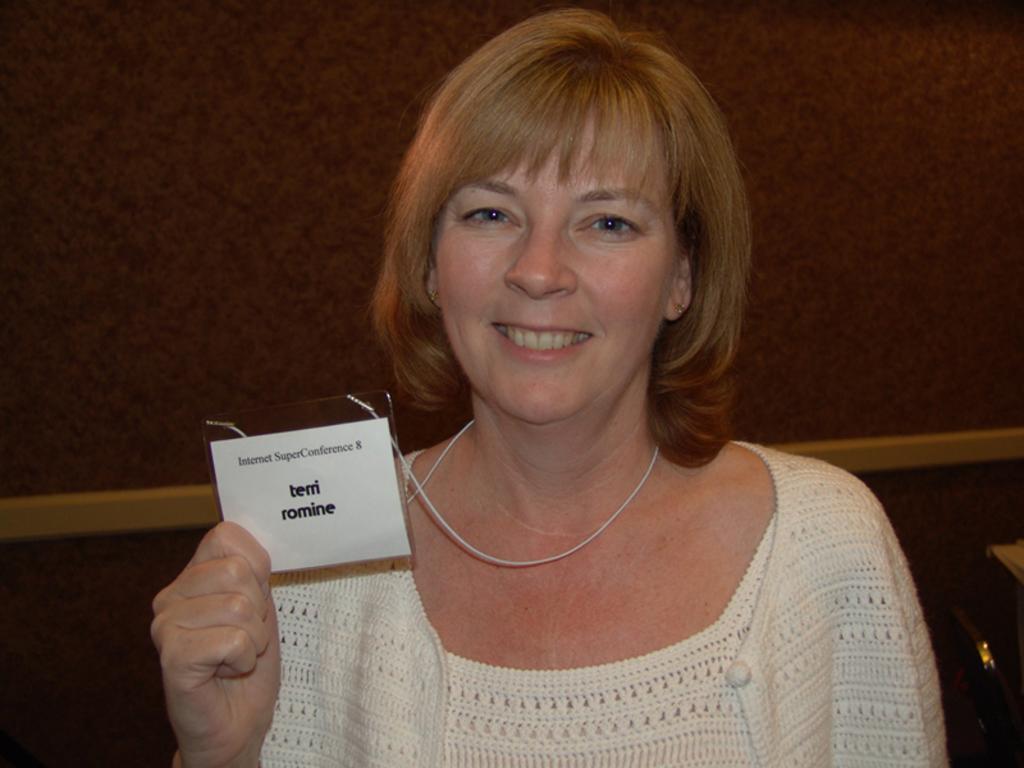Can you describe this image briefly? In this image we call see one big wall, one woman holding an ID card and some objects are on the surface. 